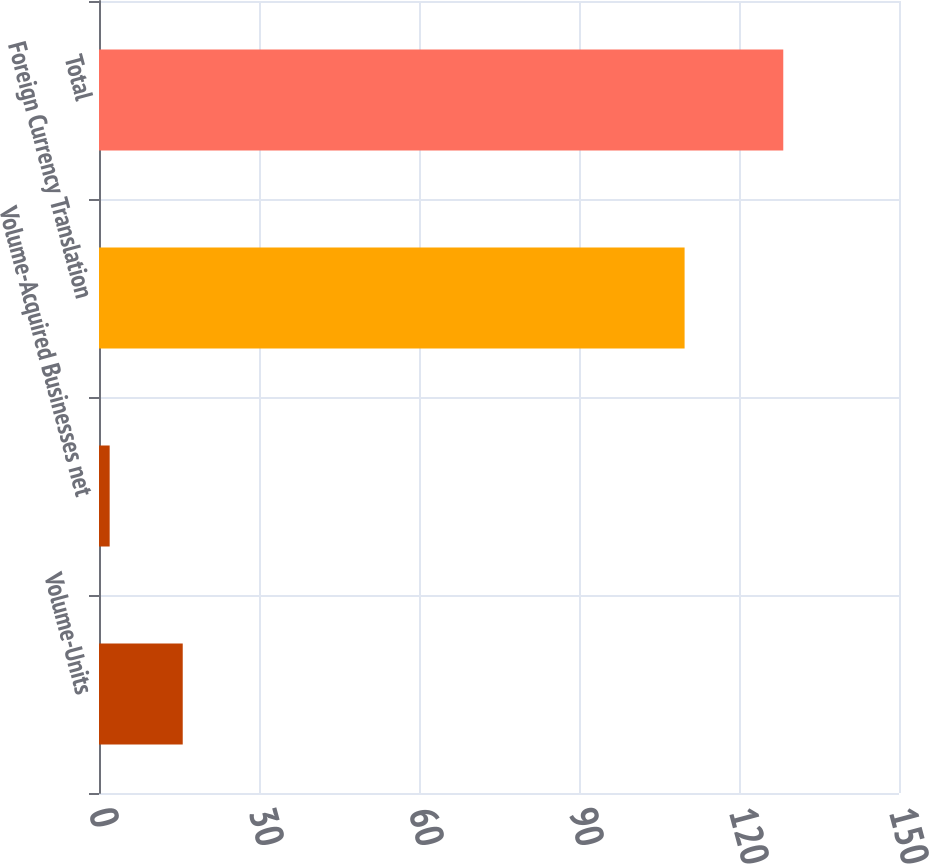Convert chart to OTSL. <chart><loc_0><loc_0><loc_500><loc_500><bar_chart><fcel>Volume-Units<fcel>Volume-Acquired Businesses net<fcel>Foreign Currency Translation<fcel>Total<nl><fcel>15.7<fcel>2<fcel>109.8<fcel>128.3<nl></chart> 